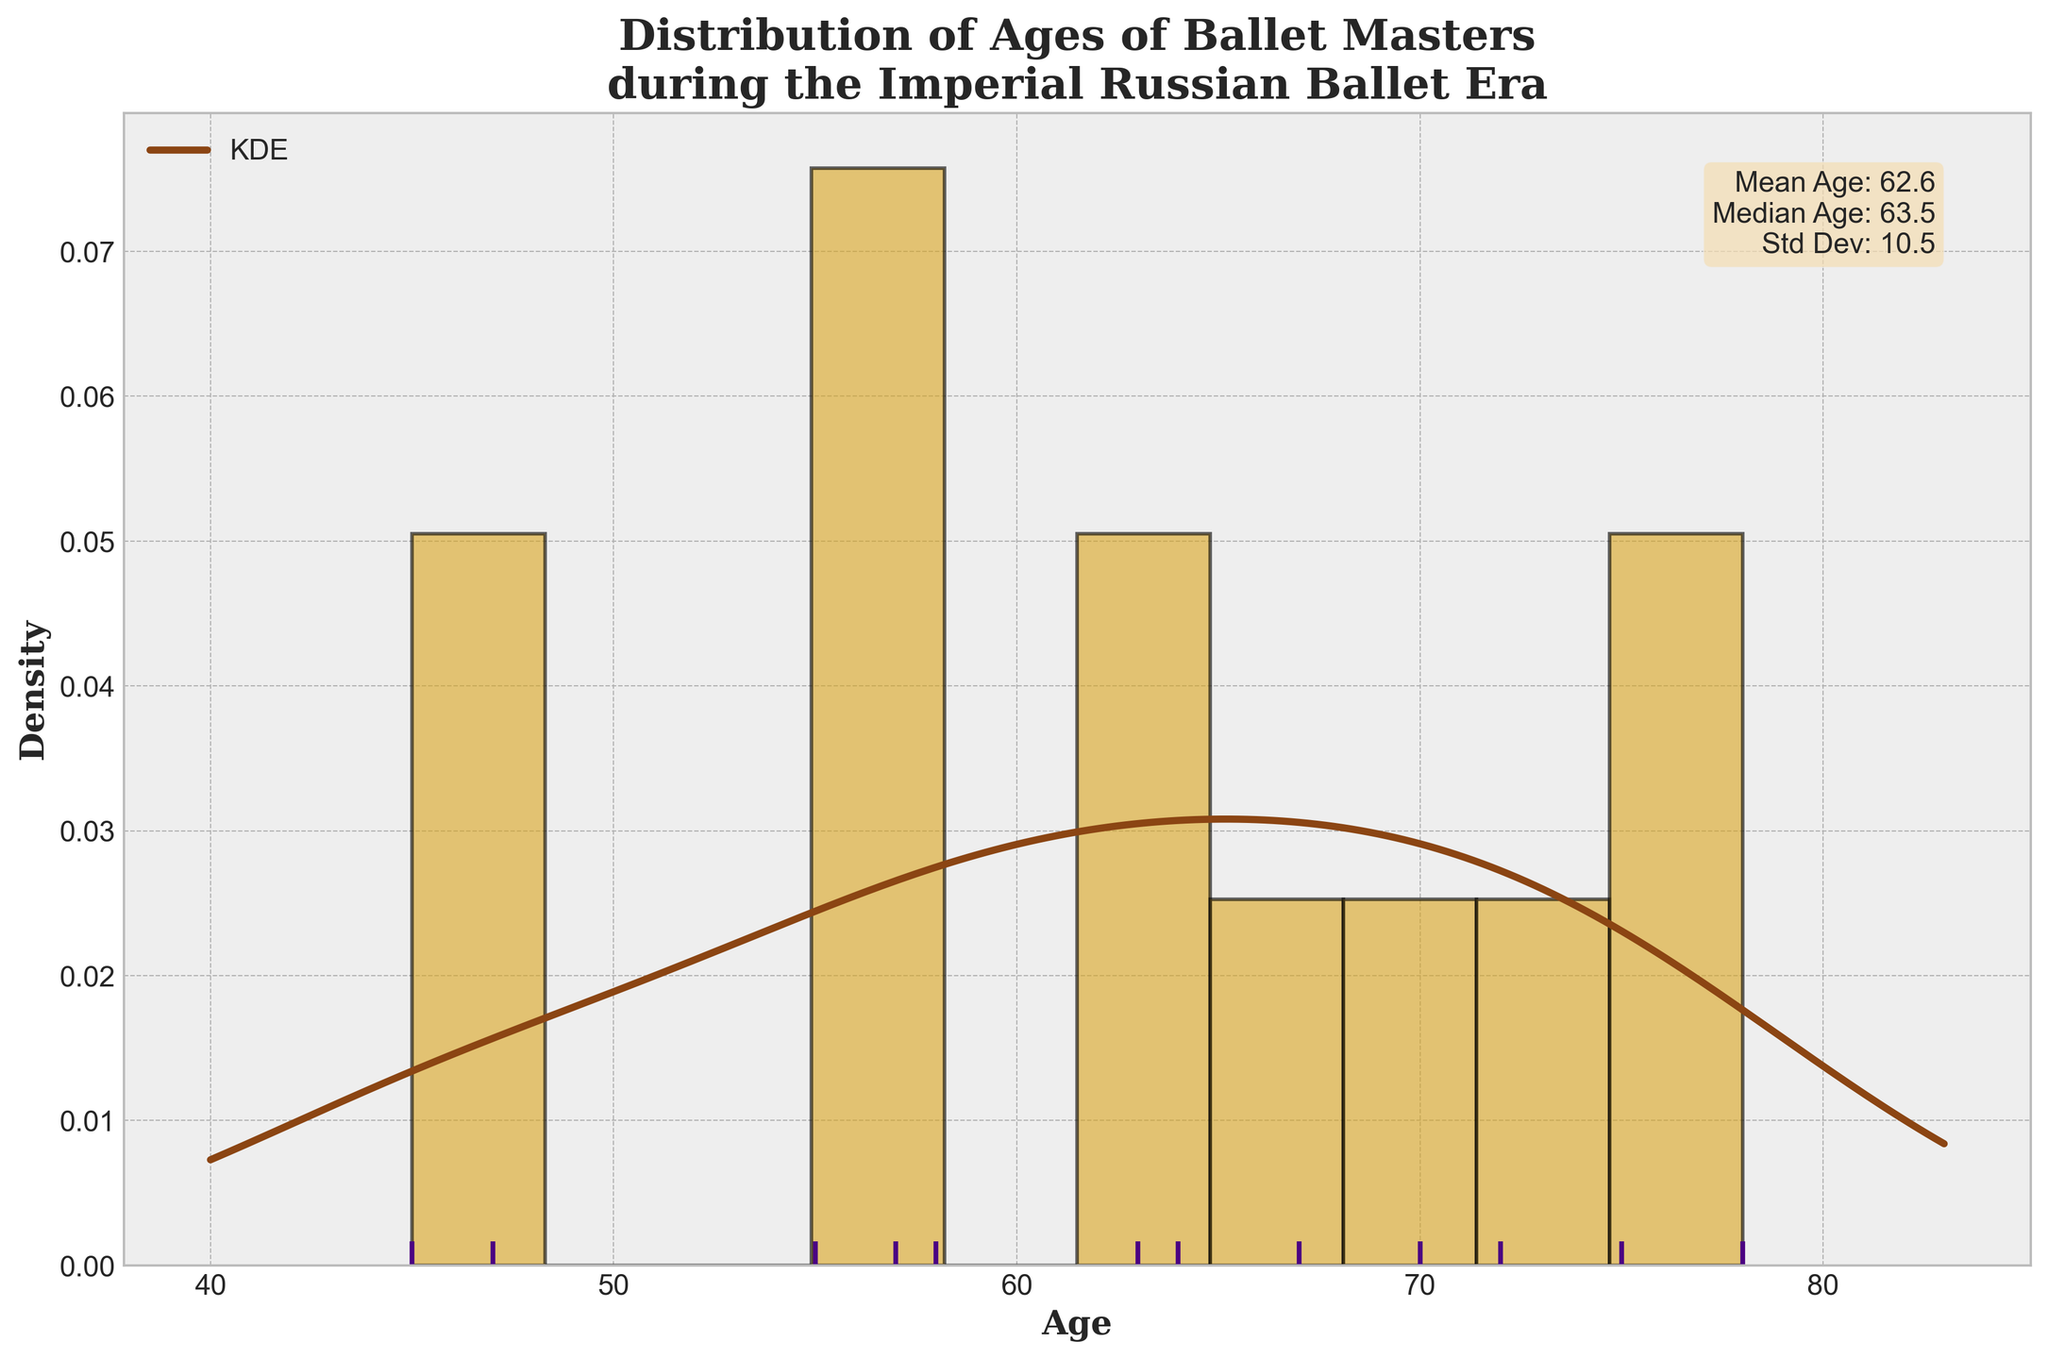What is the title of the plot? The title of the plot is displayed at the top, and it reads "Distribution of Ages of Ballet Masters during the Imperial Russian Ballet Era".
Answer: Distribution of Ages of Ballet Masters during the Imperial Russian Ballet Era What is the mean age of ballet masters during this era? The mean age is provided in the text box within the plot. It states "Mean Age: 64.9".
Answer: 64.9 How many data points are represented in the plot? The number of data points can be counted from the rug plot at the bottom, where each vertical line represents a data point. There are 12 vertical lines.
Answer: 12 What is the age range of ballet masters shown in the plot? The age range can be deduced from the x-axis, where the smallest tick mark starts at around 40 years old and the largest goes up to about 80 years old. The exact range is from 45 to 78, based on the rug plot points.
Answer: 45 to 78 Which ballet master had the longest lifespan according to the plot? The longest lifespan can be identified from the rug plot as the rightmost vertical line, which represents the age of 78, corresponding to Marius Petipa.
Answer: Marius Petipa What is the median age of ballet masters? The median age is provided within the text box in the plot, which states "Median Age: 64.0".
Answer: 64.0 What color is used for the KDE line in the plot? The color of the KDE (Kernel Density Estimate) line can be seen from its appearance, which is brown.
Answer: Brown Based on the histogram, which age group has the most ballet masters? The histogram bars represent the density of ballet masters' ages. The bar with the highest density is around the age group of 65-70.
Answer: 65-70 How does the standard deviation provide insight into the ages of ballet masters? The standard deviation, provided as "Std Dev: 10.9", indicates the variability in the ages. A standard deviation of 10.9 years suggests a moderate spread of ages around the mean, indicating the ages are relatively spread out.
Answer: It shows moderate spread around the mean Is there a significant skew in the distribution of ages? The KDE curve and the histogram both suggest the distribution is roughly symmetric around the mean, indicating no significant skew.
Answer: No significant skew 